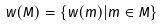Convert formula to latex. <formula><loc_0><loc_0><loc_500><loc_500>w ( M ) = \{ w ( m ) | m \in M \}</formula> 